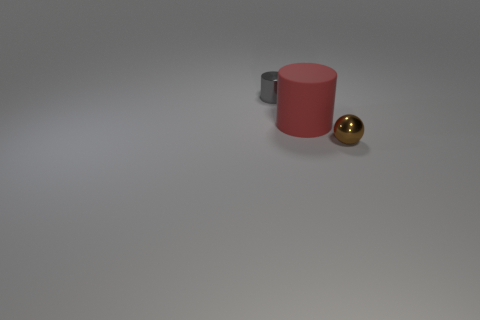Add 1 purple balls. How many objects exist? 4 Subtract all cylinders. How many objects are left? 1 Subtract all tiny red metal objects. Subtract all tiny spheres. How many objects are left? 2 Add 1 large red things. How many large red things are left? 2 Add 2 red things. How many red things exist? 3 Subtract 0 cyan spheres. How many objects are left? 3 